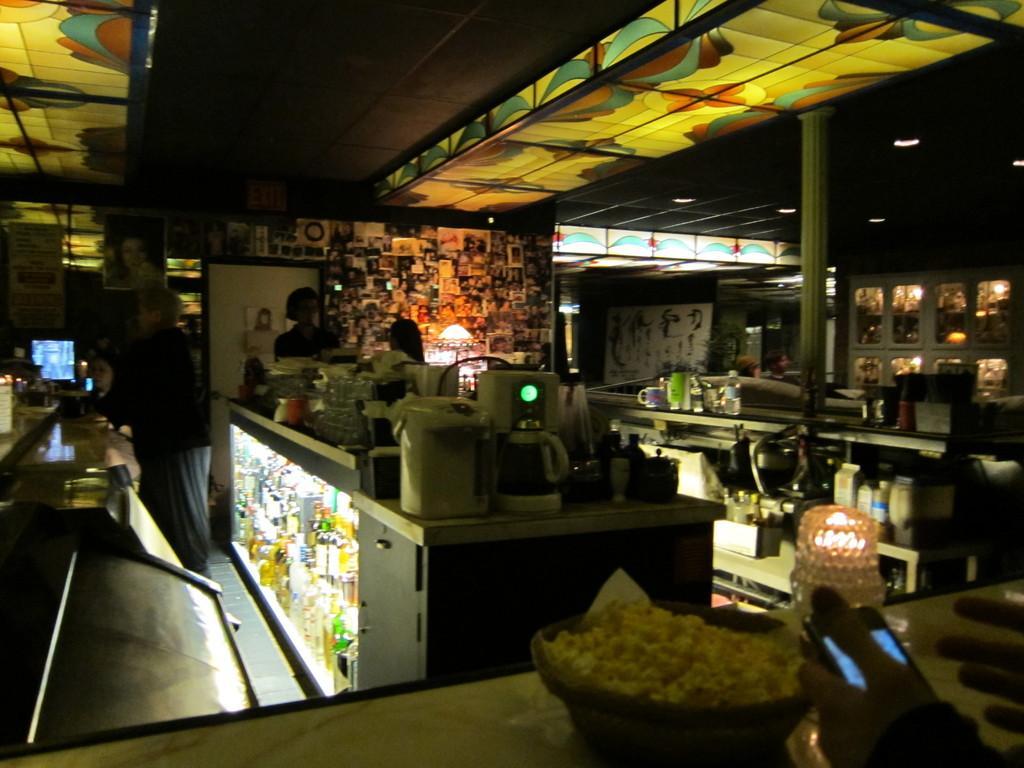Describe this image in one or two sentences. In this image I can see a few bottles,cups,machines and few objects on the tables. In front I can see a food in the bowl and a person is holding a mobile. Back I can see few people,system,pillars,lights,banners and something is attached to the wall. 